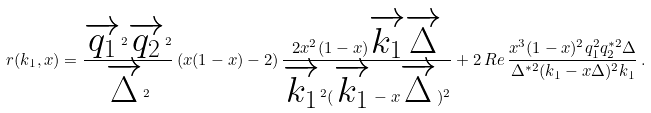<formula> <loc_0><loc_0><loc_500><loc_500>r ( k _ { 1 } , x ) = \frac { \overrightarrow { q _ { 1 } } ^ { 2 } \overrightarrow { q _ { 2 } } ^ { 2 } } { \overrightarrow { \Delta } ^ { 2 } } \left ( x ( 1 - x ) - 2 \right ) \frac { 2 x ^ { 2 } ( 1 - x ) \overrightarrow { k _ { 1 } } \overrightarrow { \Delta } } { \overrightarrow { k _ { 1 } } ^ { 2 } ( \overrightarrow { k _ { 1 } } - x \overrightarrow { \Delta } ) ^ { 2 } } + 2 \, R e \, \frac { x ^ { 3 } ( 1 - x ) ^ { 2 } q _ { 1 } ^ { 2 } q _ { 2 } ^ { * 2 } \Delta } { \Delta ^ { * 2 } ( k _ { 1 } - x \Delta ) ^ { 2 } k _ { 1 } } \, .</formula> 